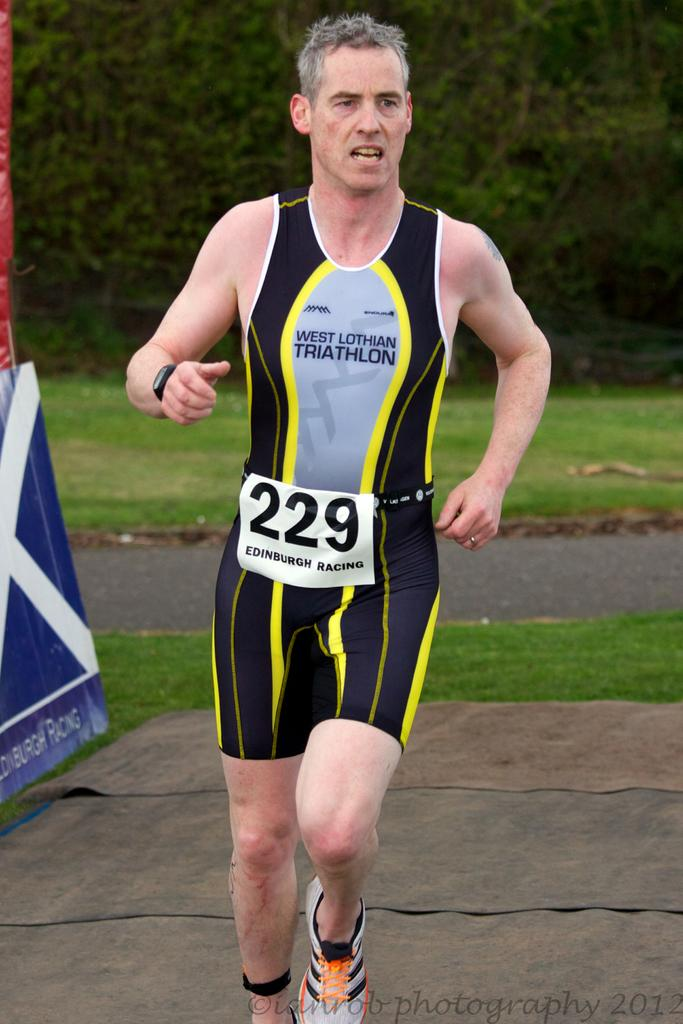<image>
Create a compact narrative representing the image presented. A runner is participating in the West Lothian Triathalon. 